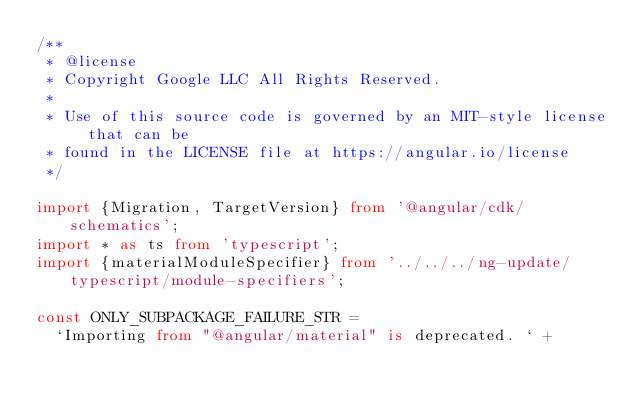<code> <loc_0><loc_0><loc_500><loc_500><_TypeScript_>/**
 * @license
 * Copyright Google LLC All Rights Reserved.
 *
 * Use of this source code is governed by an MIT-style license that can be
 * found in the LICENSE file at https://angular.io/license
 */

import {Migration, TargetVersion} from '@angular/cdk/schematics';
import * as ts from 'typescript';
import {materialModuleSpecifier} from '../../../ng-update/typescript/module-specifiers';

const ONLY_SUBPACKAGE_FAILURE_STR =
  `Importing from "@angular/material" is deprecated. ` +</code> 